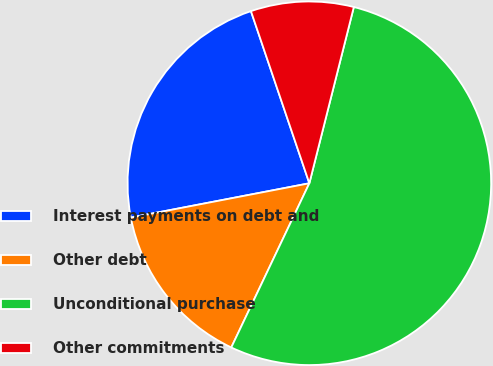<chart> <loc_0><loc_0><loc_500><loc_500><pie_chart><fcel>Interest payments on debt and<fcel>Other debt<fcel>Unconditional purchase<fcel>Other commitments<nl><fcel>22.82%<fcel>14.91%<fcel>53.13%<fcel>9.14%<nl></chart> 